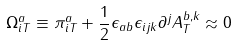<formula> <loc_0><loc_0><loc_500><loc_500>\Omega _ { i T } ^ { a } \equiv \pi _ { i T } ^ { a } + \frac { 1 } { 2 } \epsilon _ { a b } \epsilon _ { i j k } \partial ^ { j } A _ { T } ^ { b , k } \approx 0</formula> 